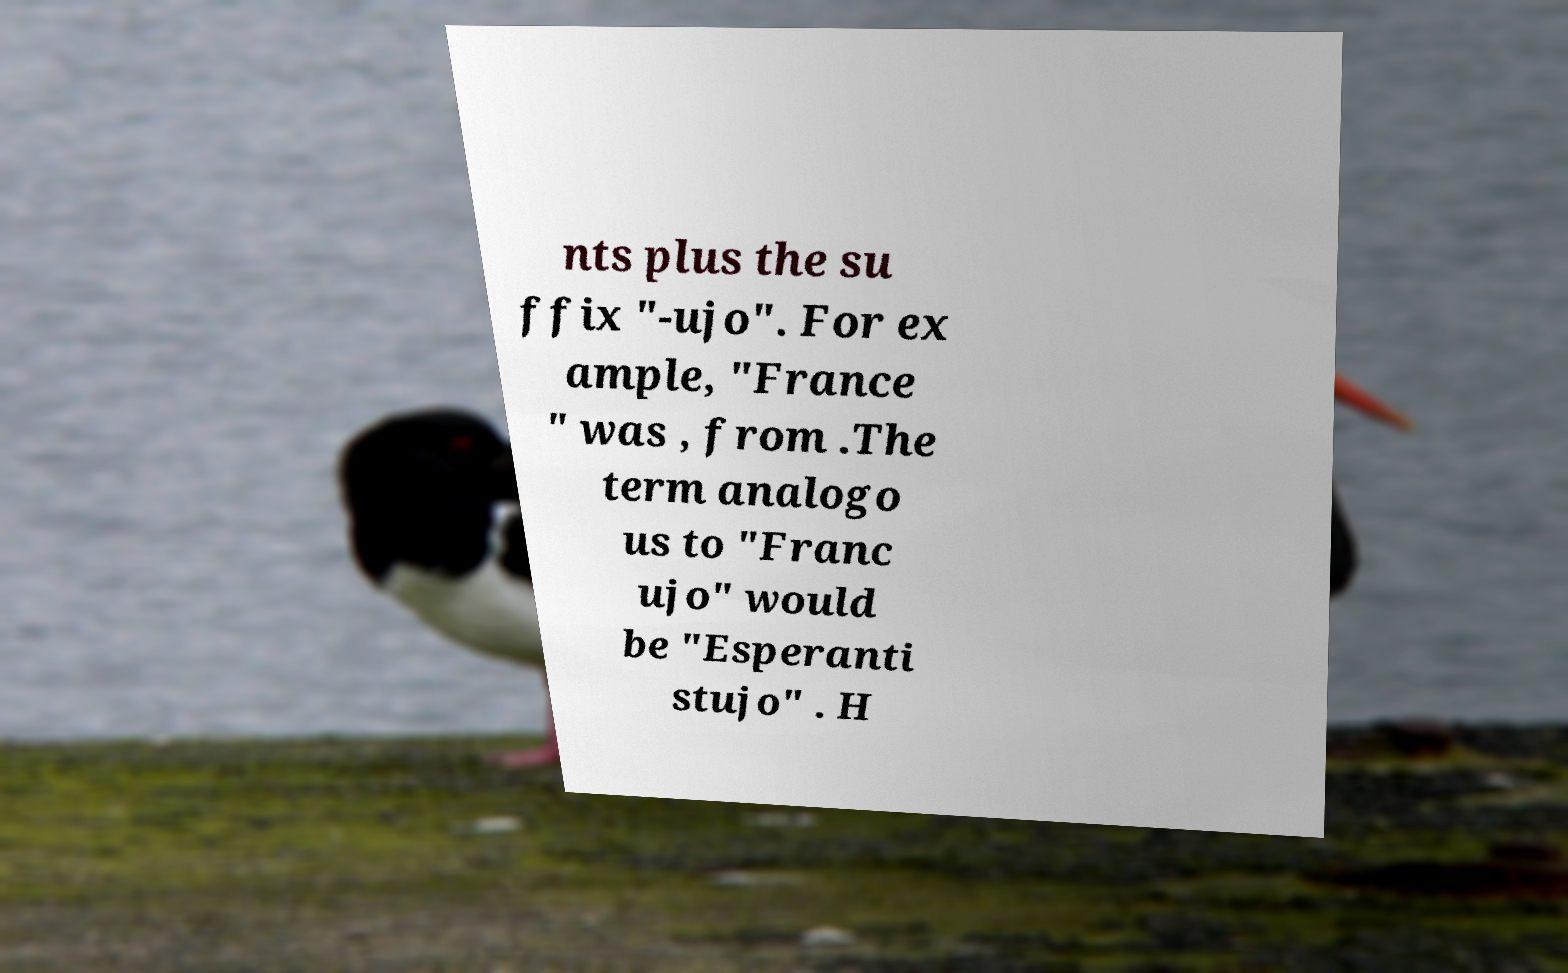Could you extract and type out the text from this image? nts plus the su ffix "-ujo". For ex ample, "France " was , from .The term analogo us to "Franc ujo" would be "Esperanti stujo" . H 